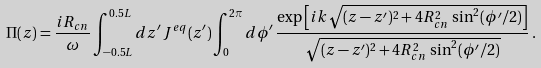<formula> <loc_0><loc_0><loc_500><loc_500>\Pi ( z ) = \frac { i R _ { c n } } { \omega } \int _ { - 0 . 5 L } ^ { 0 . 5 L } d z ^ { \prime } \, J ^ { e q } ( z ^ { \prime } ) \int _ { 0 } ^ { 2 \pi } d \phi ^ { \prime } \, \frac { \exp \left [ i k \sqrt { ( z - z ^ { \prime } ) ^ { 2 } + 4 R _ { c n } ^ { 2 } \, \sin ^ { 2 } ( \phi ^ { \prime } / 2 ) } \right ] } { \sqrt { ( z - z ^ { \prime } ) ^ { 2 } + 4 R _ { c n } ^ { 2 } \, \sin ^ { 2 } ( \phi ^ { \prime } / 2 ) } } \, .</formula> 